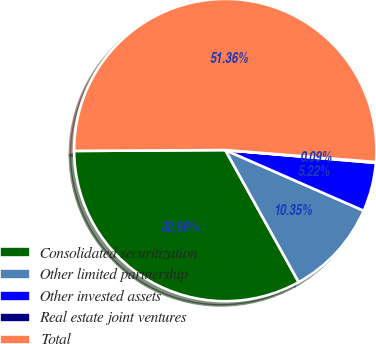Convert chart. <chart><loc_0><loc_0><loc_500><loc_500><pie_chart><fcel>Consolidated securitization<fcel>Other limited partnership<fcel>Other invested assets<fcel>Real estate joint ventures<fcel>Total<nl><fcel>32.98%<fcel>10.35%<fcel>5.22%<fcel>0.09%<fcel>51.36%<nl></chart> 